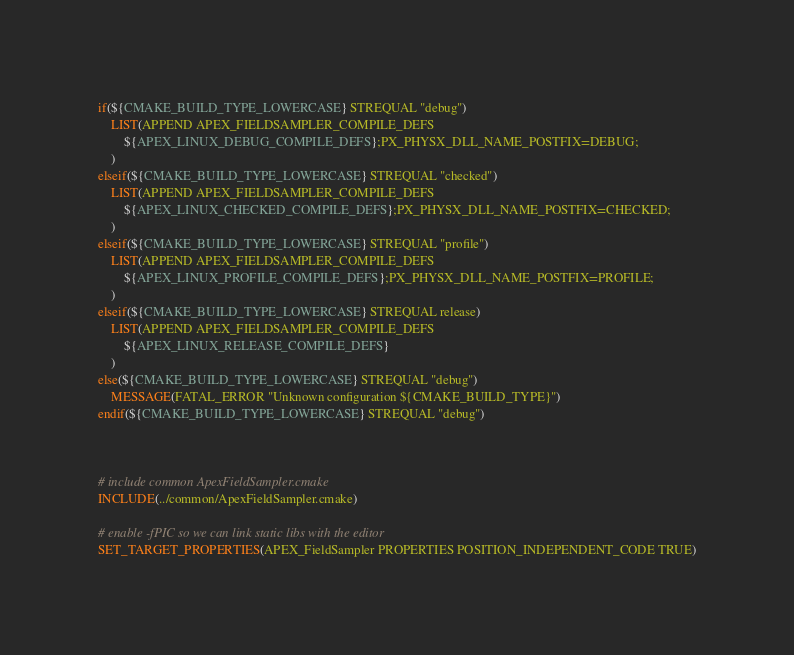Convert code to text. <code><loc_0><loc_0><loc_500><loc_500><_CMake_>
if(${CMAKE_BUILD_TYPE_LOWERCASE} STREQUAL "debug")
	LIST(APPEND APEX_FIELDSAMPLER_COMPILE_DEFS
		${APEX_LINUX_DEBUG_COMPILE_DEFS};PX_PHYSX_DLL_NAME_POSTFIX=DEBUG;
	)
elseif(${CMAKE_BUILD_TYPE_LOWERCASE} STREQUAL "checked")
	LIST(APPEND APEX_FIELDSAMPLER_COMPILE_DEFS
		${APEX_LINUX_CHECKED_COMPILE_DEFS};PX_PHYSX_DLL_NAME_POSTFIX=CHECKED;
	)
elseif(${CMAKE_BUILD_TYPE_LOWERCASE} STREQUAL "profile")
	LIST(APPEND APEX_FIELDSAMPLER_COMPILE_DEFS
		${APEX_LINUX_PROFILE_COMPILE_DEFS};PX_PHYSX_DLL_NAME_POSTFIX=PROFILE;
	)
elseif(${CMAKE_BUILD_TYPE_LOWERCASE} STREQUAL release)
	LIST(APPEND APEX_FIELDSAMPLER_COMPILE_DEFS
		${APEX_LINUX_RELEASE_COMPILE_DEFS}
	)
else(${CMAKE_BUILD_TYPE_LOWERCASE} STREQUAL "debug")
	MESSAGE(FATAL_ERROR "Unknown configuration ${CMAKE_BUILD_TYPE}")
endif(${CMAKE_BUILD_TYPE_LOWERCASE} STREQUAL "debug")



# include common ApexFieldSampler.cmake
INCLUDE(../common/ApexFieldSampler.cmake)

# enable -fPIC so we can link static libs with the editor
SET_TARGET_PROPERTIES(APEX_FieldSampler PROPERTIES POSITION_INDEPENDENT_CODE TRUE)
</code> 